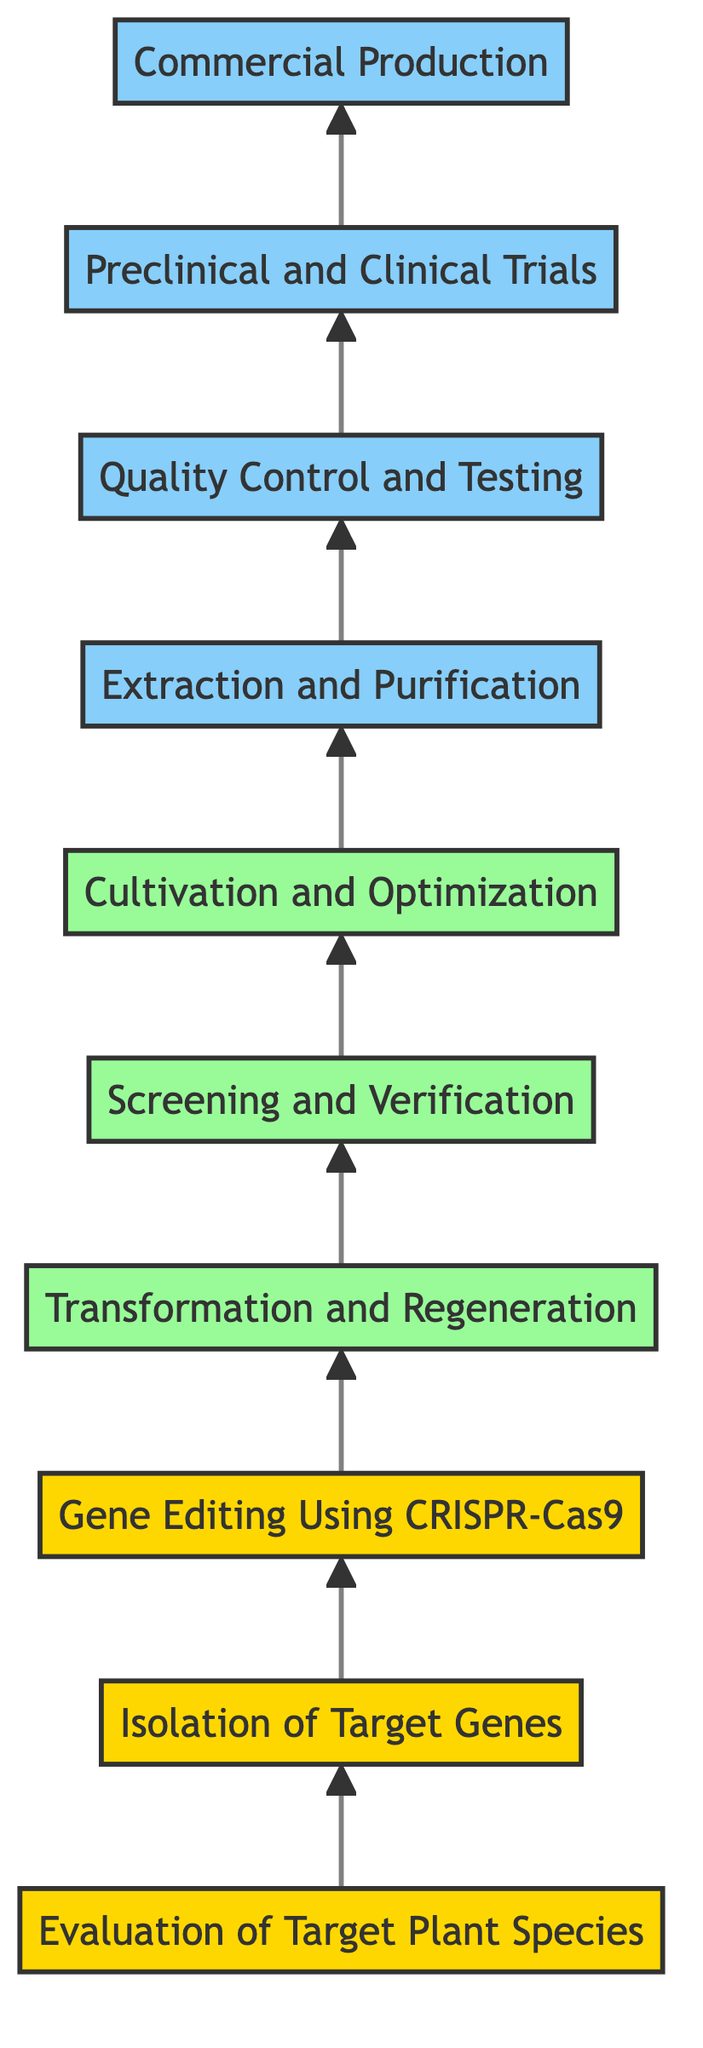What is the first step in the process? The diagram starts with the node "Evaluation of Target Plant Species," which is the first step in the process.
Answer: Evaluation of Target Plant Species How many total process steps are there? By counting the nodes in the diagram, we find there are ten distinct process steps listed.
Answer: 10 Which process step comes after "Transformation and Regeneration"? The next node following "Transformation and Regeneration" in the upward flow is "Screening and Verification."
Answer: Screening and Verification What technology is used for gene editing? The diagram specifies the use of "CRISPR-Cas9" for gene editing.
Answer: CRISPR-Cas9 In which phase does "Extraction and Purification" occur? The diagram categorizes "Extraction and Purification" under phase three, as it is listed in the group of nodes that belong to that phase.
Answer: phase three Which two steps involve verification? The diagram indicates that both "Screening and Verification" and "Quality Control and Testing" involve verification processes.
Answer: Screening and Verification, Quality Control and Testing What is the final outcome of the process depicted in the diagram? The last step in the flowchart is "Commercial Production," indicating the final outcome of the entire process.
Answer: Commercial Production How does "Cultivation and Optimization" relate to "Extraction and Purification"? "Cultivation and Optimization" directly precedes "Extraction and Purification," indicating that it is an essential step to ensure maximum compound production before extraction.
Answer: Cultivation and Optimization Identify the phase that contains steps D, E, and F. The diagram groups "Transformation and Regeneration," "Screening and Verification," and "Cultivation and Optimization" as phase two, indicating what they all have in common.
Answer: phase two 